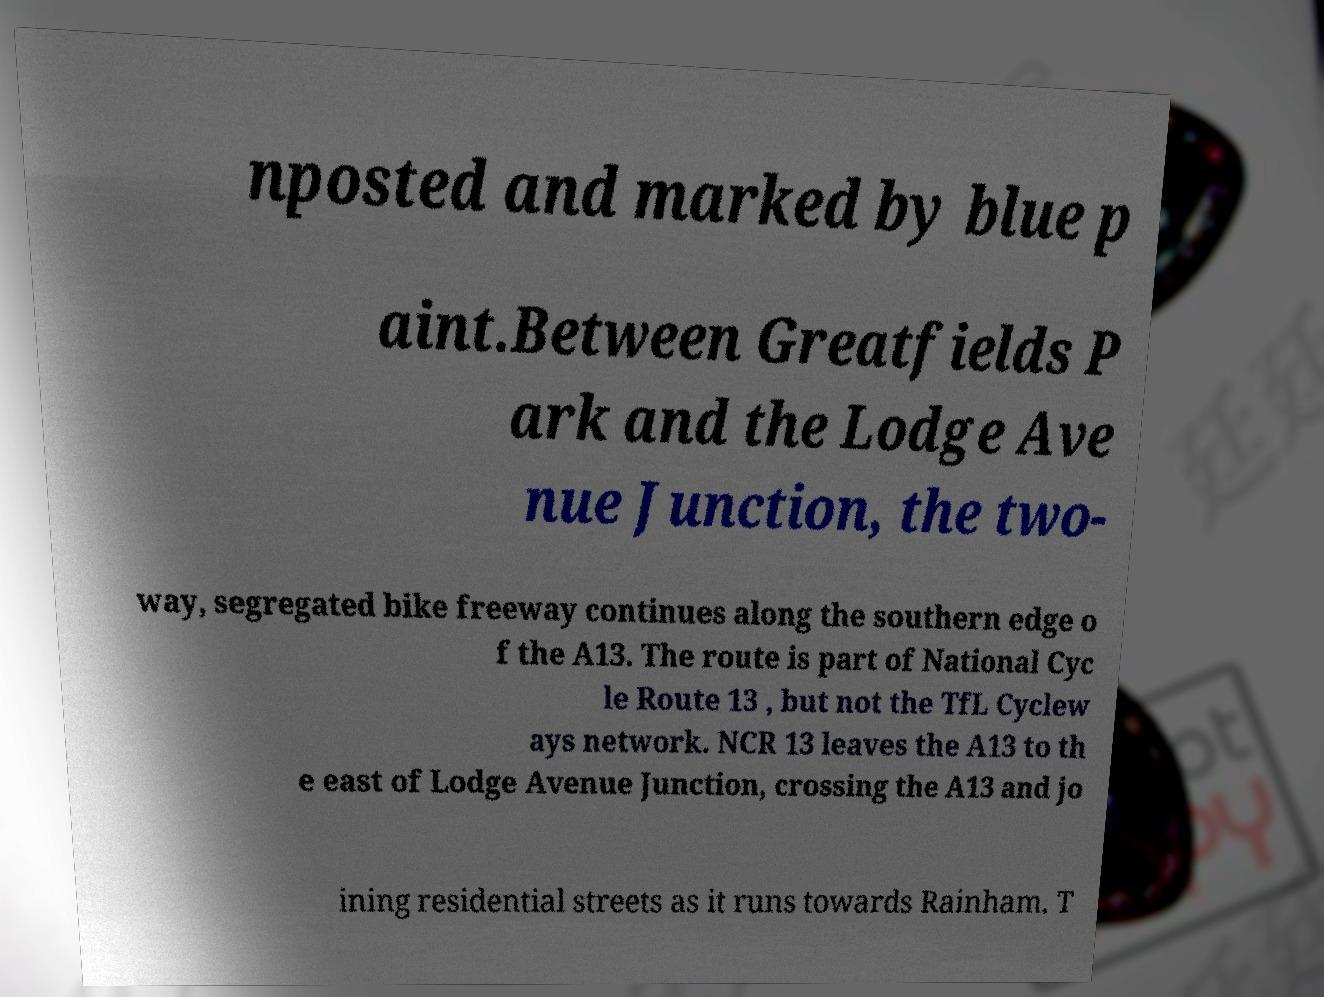I need the written content from this picture converted into text. Can you do that? nposted and marked by blue p aint.Between Greatfields P ark and the Lodge Ave nue Junction, the two- way, segregated bike freeway continues along the southern edge o f the A13. The route is part of National Cyc le Route 13 , but not the TfL Cyclew ays network. NCR 13 leaves the A13 to th e east of Lodge Avenue Junction, crossing the A13 and jo ining residential streets as it runs towards Rainham. T 